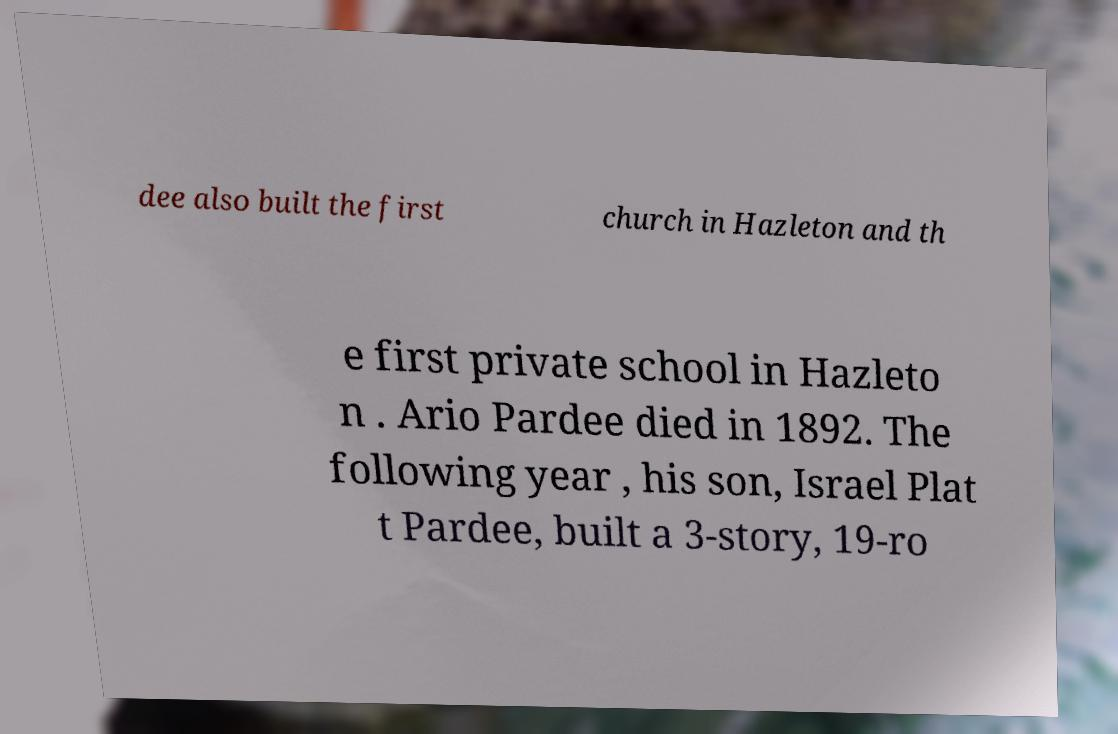Could you assist in decoding the text presented in this image and type it out clearly? dee also built the first church in Hazleton and th e first private school in Hazleto n . Ario Pardee died in 1892. The following year , his son, Israel Plat t Pardee, built a 3-story, 19-ro 